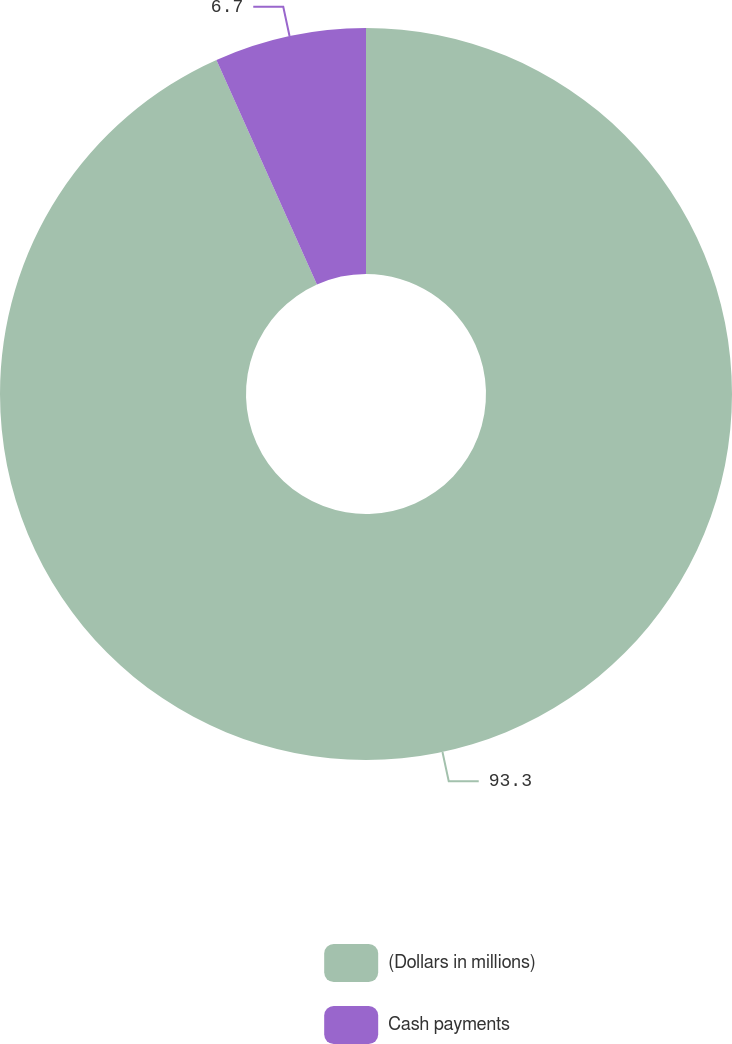Convert chart to OTSL. <chart><loc_0><loc_0><loc_500><loc_500><pie_chart><fcel>(Dollars in millions)<fcel>Cash payments<nl><fcel>93.3%<fcel>6.7%<nl></chart> 